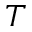Convert formula to latex. <formula><loc_0><loc_0><loc_500><loc_500>T</formula> 